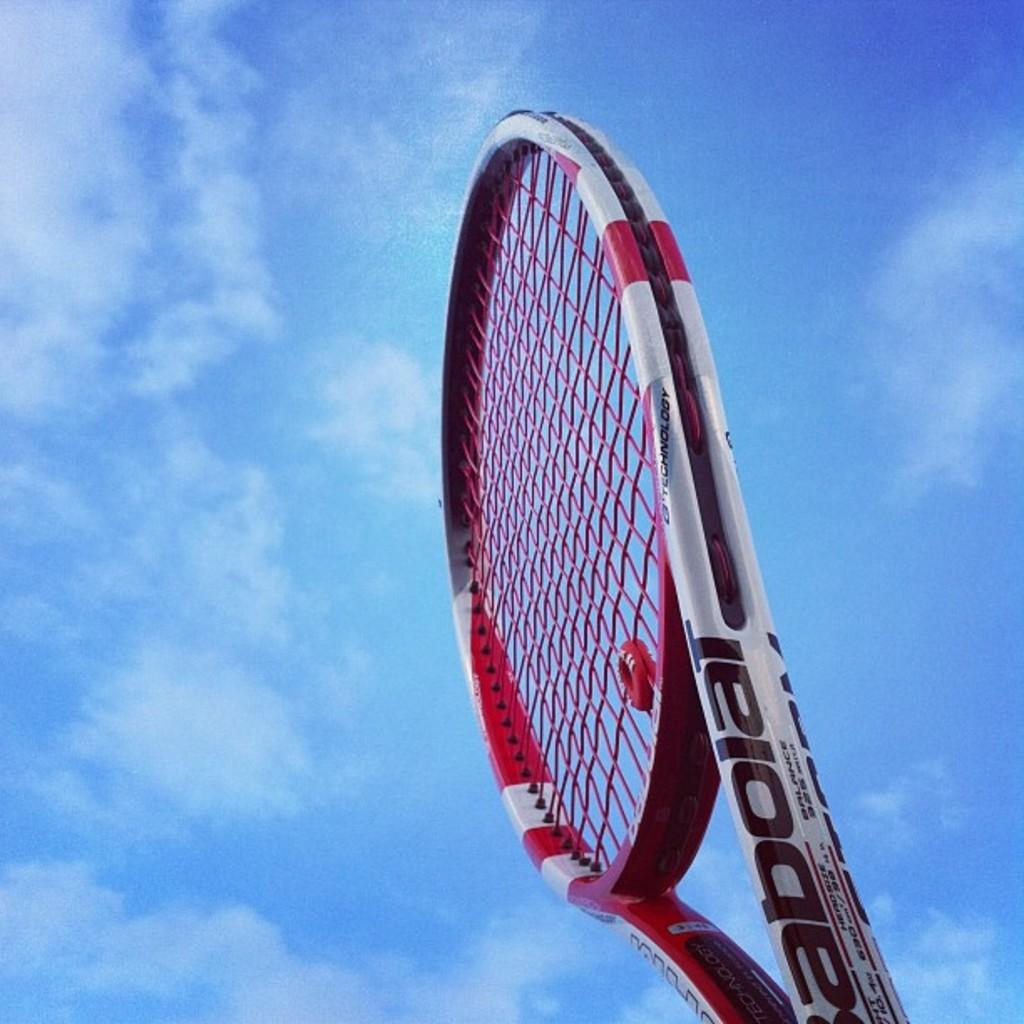Can you describe this image briefly? In this image I can see a tennis bat which is white, red and black in color. I can see the sky in the background. 